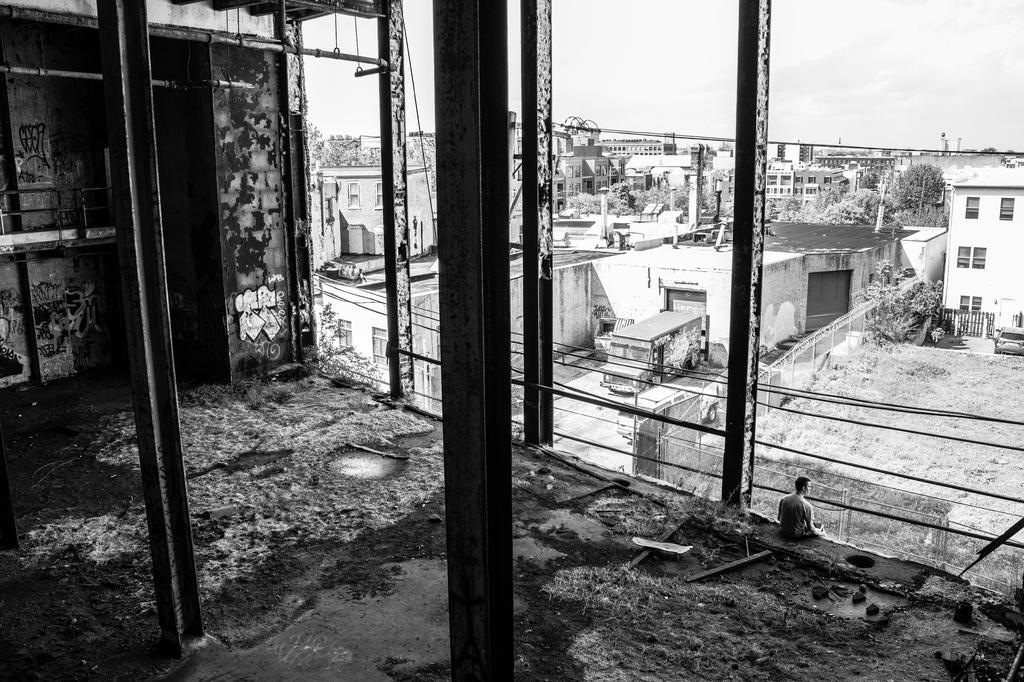How would you summarize this image in a sentence or two? This is a black and white picture, there is a man sitting on the floor of a half constructed building and in the front there are buildings all over the place with a truck in the middle and above its sky. 